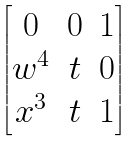Convert formula to latex. <formula><loc_0><loc_0><loc_500><loc_500>\begin{bmatrix} 0 & 0 & 1 \\ w ^ { 4 } & t & 0 \\ x ^ { 3 } & t & 1 \end{bmatrix}</formula> 